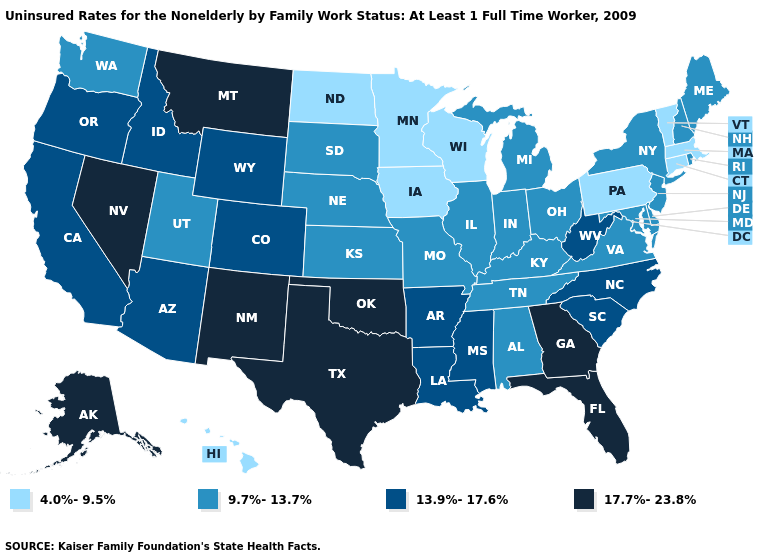Does Montana have the highest value in the USA?
Quick response, please. Yes. Name the states that have a value in the range 9.7%-13.7%?
Be succinct. Alabama, Delaware, Illinois, Indiana, Kansas, Kentucky, Maine, Maryland, Michigan, Missouri, Nebraska, New Hampshire, New Jersey, New York, Ohio, Rhode Island, South Dakota, Tennessee, Utah, Virginia, Washington. Which states have the lowest value in the USA?
Short answer required. Connecticut, Hawaii, Iowa, Massachusetts, Minnesota, North Dakota, Pennsylvania, Vermont, Wisconsin. What is the lowest value in the USA?
Write a very short answer. 4.0%-9.5%. What is the value of Virginia?
Write a very short answer. 9.7%-13.7%. What is the highest value in states that border Ohio?
Short answer required. 13.9%-17.6%. What is the lowest value in the USA?
Quick response, please. 4.0%-9.5%. What is the value of Oklahoma?
Answer briefly. 17.7%-23.8%. Does the map have missing data?
Quick response, please. No. Does Texas have the lowest value in the South?
Be succinct. No. Which states have the highest value in the USA?
Be succinct. Alaska, Florida, Georgia, Montana, Nevada, New Mexico, Oklahoma, Texas. Name the states that have a value in the range 17.7%-23.8%?
Keep it brief. Alaska, Florida, Georgia, Montana, Nevada, New Mexico, Oklahoma, Texas. What is the value of Maine?
Give a very brief answer. 9.7%-13.7%. Which states have the lowest value in the South?
Quick response, please. Alabama, Delaware, Kentucky, Maryland, Tennessee, Virginia. Name the states that have a value in the range 13.9%-17.6%?
Write a very short answer. Arizona, Arkansas, California, Colorado, Idaho, Louisiana, Mississippi, North Carolina, Oregon, South Carolina, West Virginia, Wyoming. 